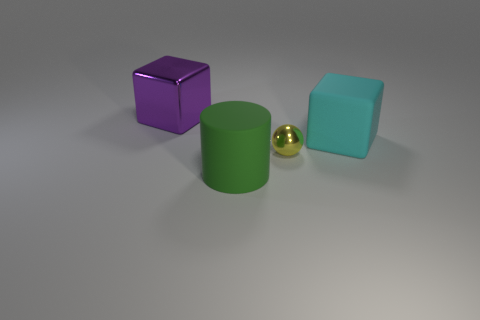Can you describe the texture of the surface on which the objects are placed? The surface upon which the objects are resting seems to have a relatively smooth texture with a matte finish. There's a soft diffuse reflection hinting at a non-glossy material, such as brushed metal or a matte-painted surface, which allows for subtle reflection of light without significant glare. Does the texture contribute to the overall aesthetics of the scene? Certainly, the subtle texture of the surface contributes to the overall aesthetics by providing a gentle contrast to the smooth and reflective materials of the objects. This interplay of textures creates a visually pleasing balance and helps to draw the viewer’s attention to the individual characteristics of each object. 